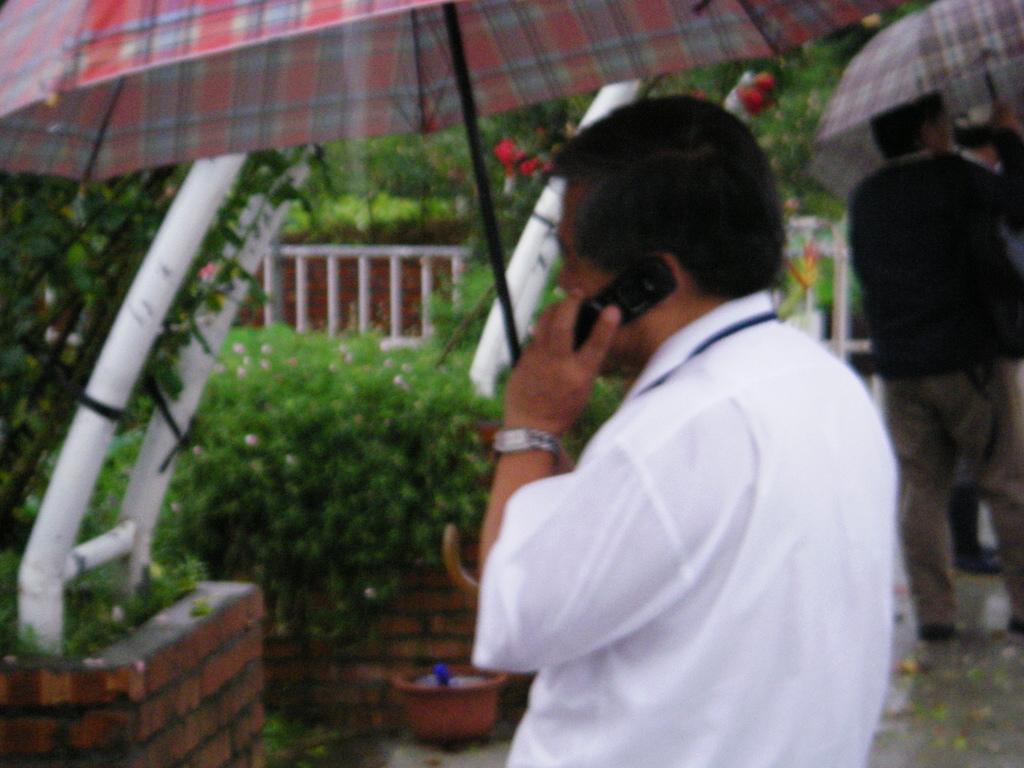Can you describe this image briefly? In the picture I can see a man on the right side and looks like he is speaking on a mobile phone. He is wearing a white color shirt and there is a watch in his left hand. I can see another person on the top right side. In the background, I can see the tents, plants, metal fence and trees. 